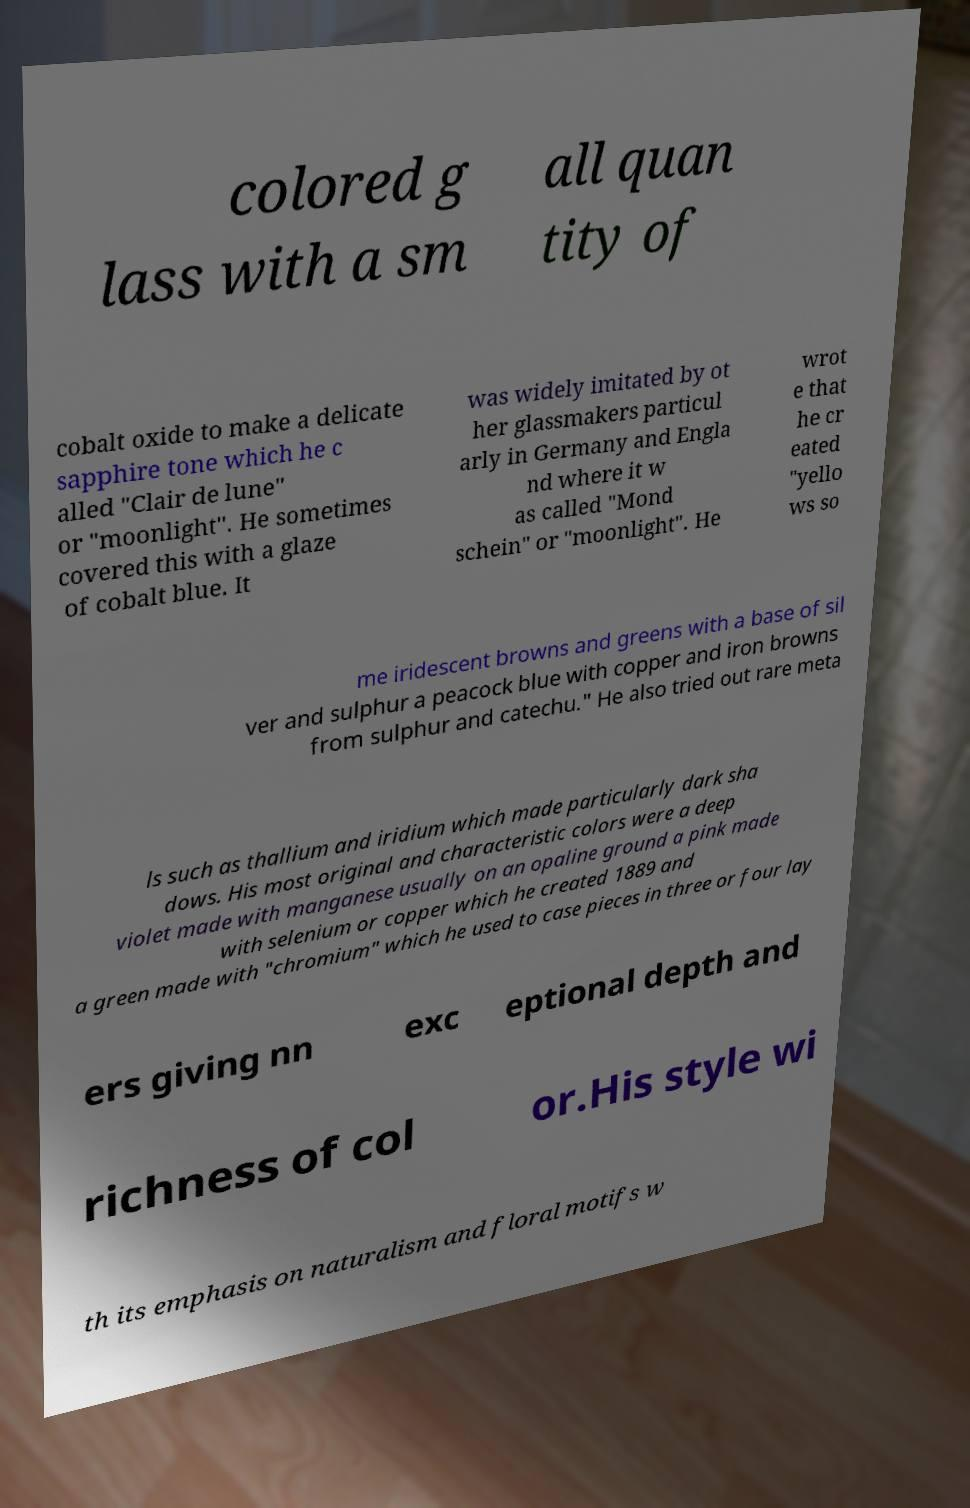Could you assist in decoding the text presented in this image and type it out clearly? colored g lass with a sm all quan tity of cobalt oxide to make a delicate sapphire tone which he c alled "Clair de lune" or "moonlight". He sometimes covered this with a glaze of cobalt blue. It was widely imitated by ot her glassmakers particul arly in Germany and Engla nd where it w as called "Mond schein" or "moonlight". He wrot e that he cr eated "yello ws so me iridescent browns and greens with a base of sil ver and sulphur a peacock blue with copper and iron browns from sulphur and catechu." He also tried out rare meta ls such as thallium and iridium which made particularly dark sha dows. His most original and characteristic colors were a deep violet made with manganese usually on an opaline ground a pink made with selenium or copper which he created 1889 and a green made with "chromium" which he used to case pieces in three or four lay ers giving nn exc eptional depth and richness of col or.His style wi th its emphasis on naturalism and floral motifs w 